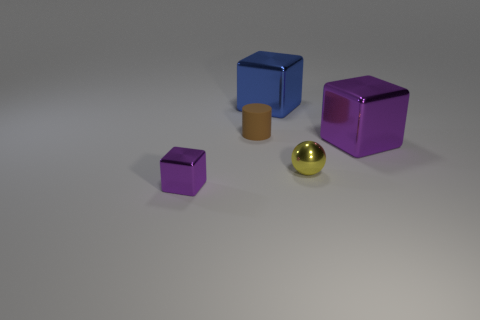Is there any other thing of the same color as the tiny matte cylinder?
Provide a short and direct response. No. What is the shape of the big blue object that is the same material as the small yellow object?
Make the answer very short. Cube. What size is the purple cube that is on the right side of the brown rubber cylinder?
Ensure brevity in your answer.  Large. What is the shape of the brown object?
Your response must be concise. Cylinder. Is the size of the brown thing that is behind the tiny purple metal cube the same as the purple metal block on the right side of the blue cube?
Give a very brief answer. No. There is a purple cube left of the purple metallic object behind the purple cube that is in front of the small ball; what is its size?
Give a very brief answer. Small. What shape is the tiny object behind the purple metal cube right of the large shiny thing to the left of the large purple metallic block?
Your response must be concise. Cylinder. There is a tiny metallic object that is on the left side of the sphere; what shape is it?
Give a very brief answer. Cube. Is the material of the large blue cube the same as the purple block that is to the right of the blue metallic block?
Offer a terse response. Yes. How many other objects are the same shape as the tiny yellow metallic object?
Your answer should be compact. 0. 